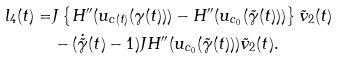Convert formula to latex. <formula><loc_0><loc_0><loc_500><loc_500>l _ { 4 } ( t ) = & J \left \{ H ^ { \prime \prime } ( u _ { c ( t ) } ( \gamma ( t ) ) ) - H ^ { \prime \prime } ( u _ { c _ { 0 } } ( \tilde { \gamma } ( t ) ) ) \right \} \tilde { v } _ { 2 } ( t ) \\ & - ( \dot { \tilde { \gamma } } ( t ) - 1 ) J H ^ { \prime \prime } ( u _ { c _ { 0 } } ( \tilde { \gamma } ( t ) ) ) \tilde { v } _ { 2 } ( t ) .</formula> 